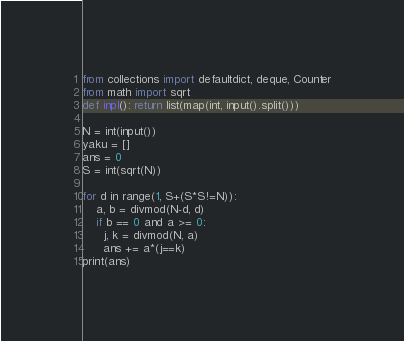<code> <loc_0><loc_0><loc_500><loc_500><_Python_>from collections import defaultdict, deque, Counter
from math import sqrt
def inpl(): return list(map(int, input().split()))

N = int(input())
yaku = []
ans = 0
S = int(sqrt(N))

for d in range(1, S+(S*S!=N)):
    a, b = divmod(N-d, d)
    if b == 0 and a >= 0:
      j, k = divmod(N, a)
      ans += a*(j==k)
print(ans)</code> 